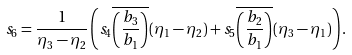Convert formula to latex. <formula><loc_0><loc_0><loc_500><loc_500>s _ { 6 } = \frac { 1 } { \eta _ { 3 } - \eta _ { 2 } } \left ( s _ { 4 } \overline { \left ( \frac { b _ { 3 } } { b _ { 1 } } \right ) } ( \eta _ { 1 } - \eta _ { 2 } ) + s _ { 5 } \overline { \left ( \frac { b _ { 2 } } { b _ { 1 } } \right ) } ( \eta _ { 3 } - \eta _ { 1 } ) \right ) .</formula> 